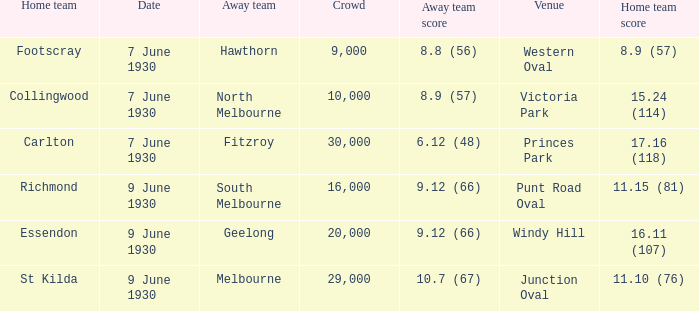At which location did the away team score Victoria Park. 